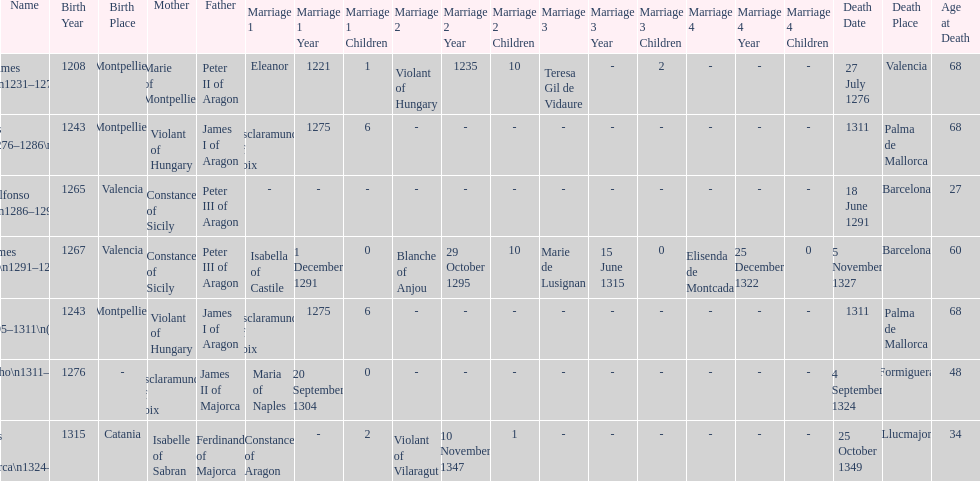Which monarch is listed first? James I 1231-1276. 